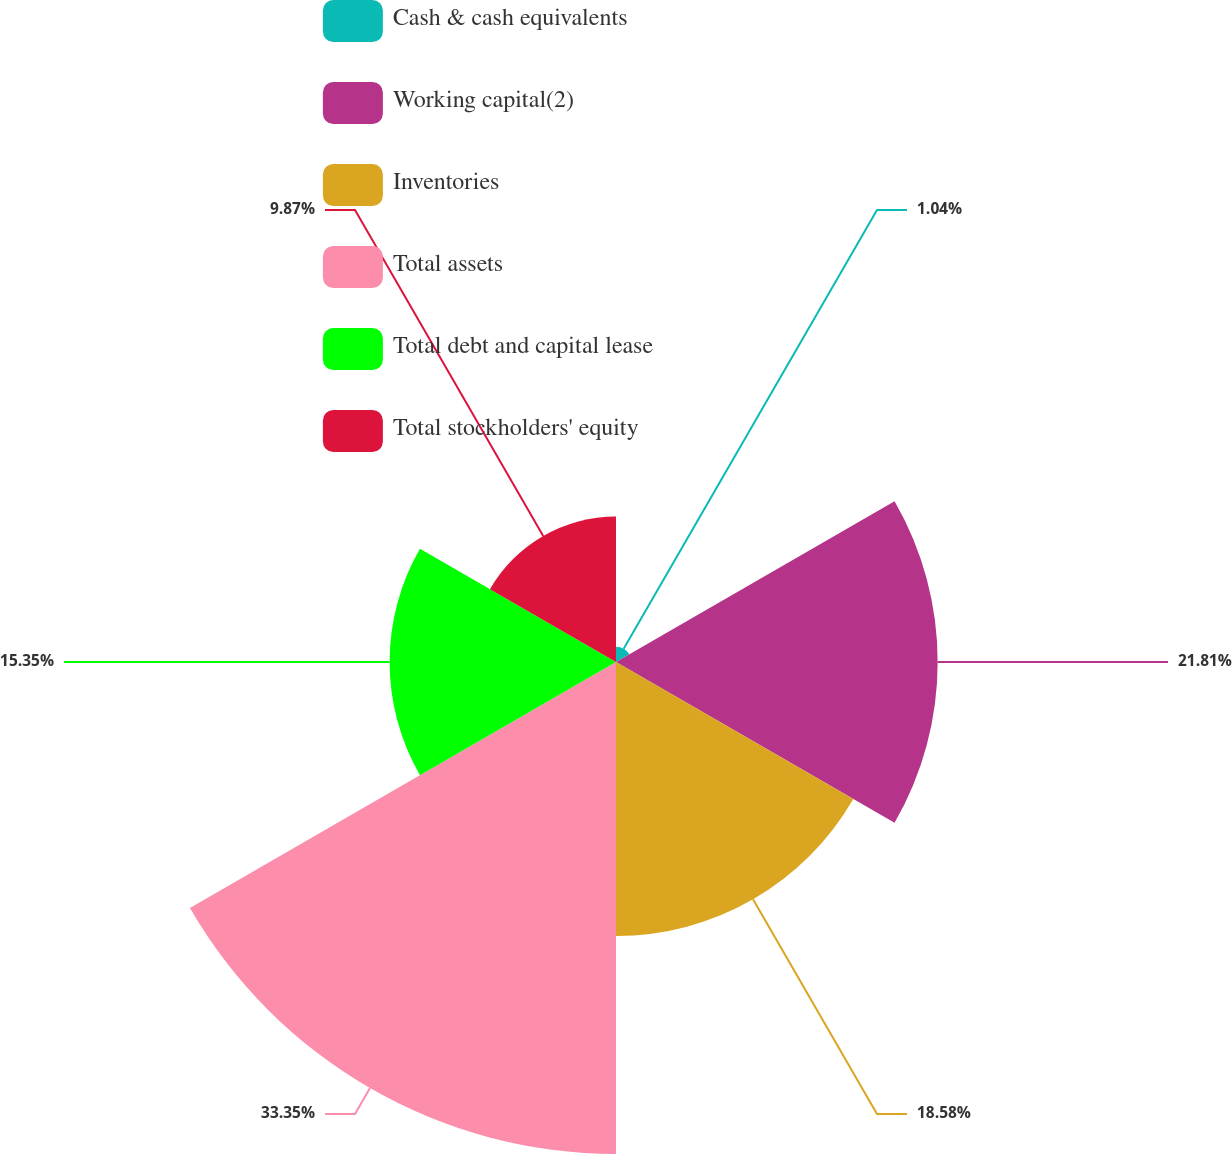<chart> <loc_0><loc_0><loc_500><loc_500><pie_chart><fcel>Cash & cash equivalents<fcel>Working capital(2)<fcel>Inventories<fcel>Total assets<fcel>Total debt and capital lease<fcel>Total stockholders' equity<nl><fcel>1.04%<fcel>21.81%<fcel>18.58%<fcel>33.36%<fcel>15.35%<fcel>9.87%<nl></chart> 